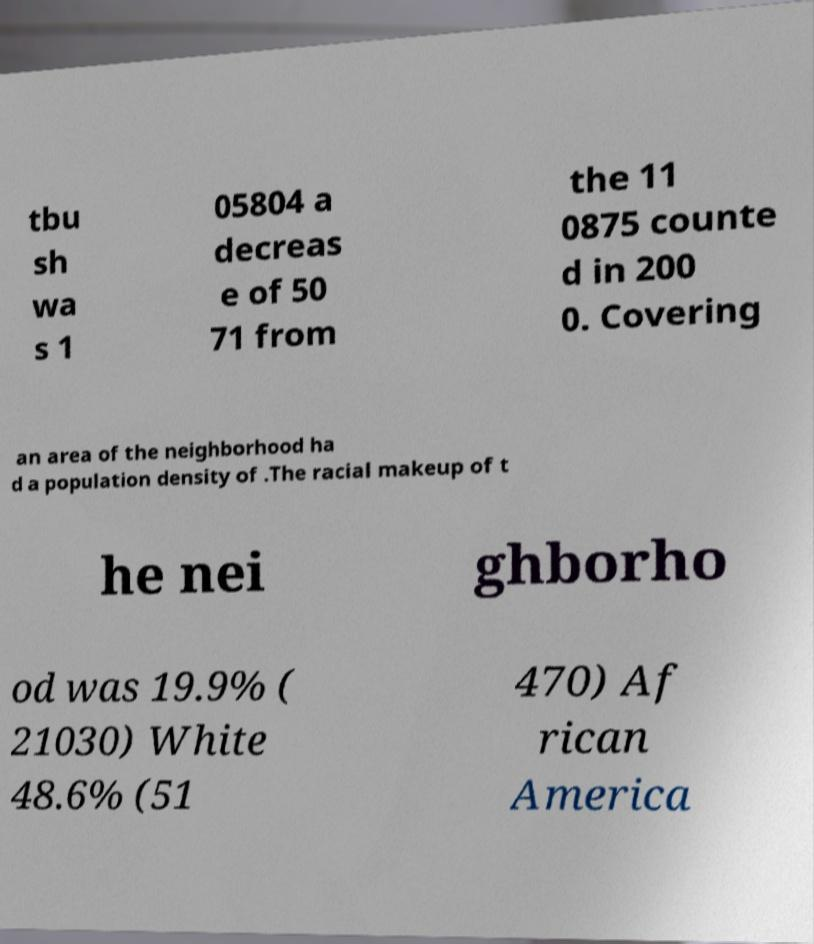I need the written content from this picture converted into text. Can you do that? tbu sh wa s 1 05804 a decreas e of 50 71 from the 11 0875 counte d in 200 0. Covering an area of the neighborhood ha d a population density of .The racial makeup of t he nei ghborho od was 19.9% ( 21030) White 48.6% (51 470) Af rican America 